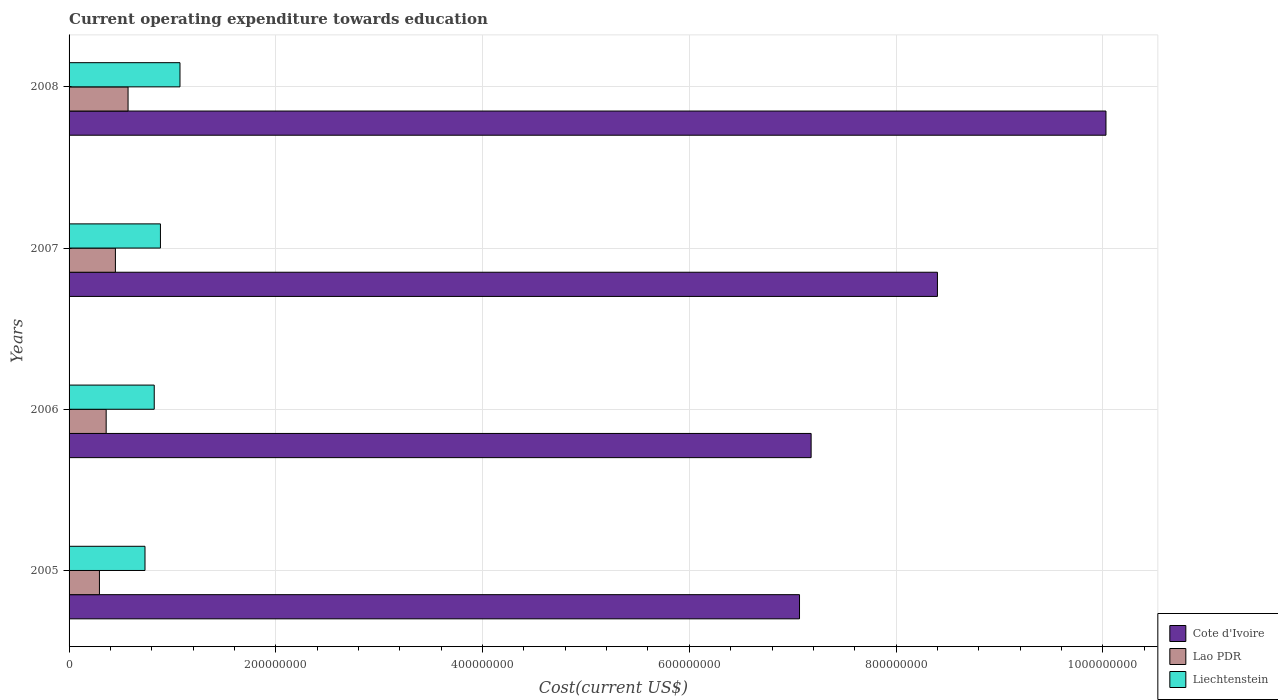How many different coloured bars are there?
Offer a very short reply. 3. Are the number of bars per tick equal to the number of legend labels?
Offer a very short reply. Yes. Are the number of bars on each tick of the Y-axis equal?
Your answer should be very brief. Yes. How many bars are there on the 2nd tick from the top?
Provide a succinct answer. 3. How many bars are there on the 1st tick from the bottom?
Provide a succinct answer. 3. What is the expenditure towards education in Liechtenstein in 2008?
Your answer should be very brief. 1.07e+08. Across all years, what is the maximum expenditure towards education in Liechtenstein?
Offer a terse response. 1.07e+08. Across all years, what is the minimum expenditure towards education in Cote d'Ivoire?
Keep it short and to the point. 7.07e+08. In which year was the expenditure towards education in Cote d'Ivoire minimum?
Provide a short and direct response. 2005. What is the total expenditure towards education in Lao PDR in the graph?
Keep it short and to the point. 1.67e+08. What is the difference between the expenditure towards education in Liechtenstein in 2006 and that in 2007?
Ensure brevity in your answer.  -6.00e+06. What is the difference between the expenditure towards education in Liechtenstein in 2006 and the expenditure towards education in Lao PDR in 2008?
Offer a terse response. 2.53e+07. What is the average expenditure towards education in Liechtenstein per year?
Keep it short and to the point. 8.79e+07. In the year 2007, what is the difference between the expenditure towards education in Liechtenstein and expenditure towards education in Lao PDR?
Ensure brevity in your answer.  4.36e+07. What is the ratio of the expenditure towards education in Lao PDR in 2007 to that in 2008?
Make the answer very short. 0.79. Is the difference between the expenditure towards education in Liechtenstein in 2005 and 2007 greater than the difference between the expenditure towards education in Lao PDR in 2005 and 2007?
Keep it short and to the point. Yes. What is the difference between the highest and the second highest expenditure towards education in Lao PDR?
Make the answer very short. 1.22e+07. What is the difference between the highest and the lowest expenditure towards education in Liechtenstein?
Make the answer very short. 3.39e+07. What does the 2nd bar from the top in 2007 represents?
Your response must be concise. Lao PDR. What does the 3rd bar from the bottom in 2006 represents?
Your answer should be very brief. Liechtenstein. Is it the case that in every year, the sum of the expenditure towards education in Cote d'Ivoire and expenditure towards education in Lao PDR is greater than the expenditure towards education in Liechtenstein?
Your response must be concise. Yes. How many years are there in the graph?
Make the answer very short. 4. Are the values on the major ticks of X-axis written in scientific E-notation?
Your answer should be compact. No. Does the graph contain grids?
Offer a very short reply. Yes. Where does the legend appear in the graph?
Provide a short and direct response. Bottom right. How many legend labels are there?
Your answer should be compact. 3. How are the legend labels stacked?
Your response must be concise. Vertical. What is the title of the graph?
Your response must be concise. Current operating expenditure towards education. Does "Sint Maarten (Dutch part)" appear as one of the legend labels in the graph?
Make the answer very short. No. What is the label or title of the X-axis?
Ensure brevity in your answer.  Cost(current US$). What is the Cost(current US$) of Cote d'Ivoire in 2005?
Your answer should be compact. 7.07e+08. What is the Cost(current US$) of Lao PDR in 2005?
Offer a terse response. 2.94e+07. What is the Cost(current US$) in Liechtenstein in 2005?
Provide a succinct answer. 7.34e+07. What is the Cost(current US$) of Cote d'Ivoire in 2006?
Offer a terse response. 7.18e+08. What is the Cost(current US$) of Lao PDR in 2006?
Your response must be concise. 3.59e+07. What is the Cost(current US$) in Liechtenstein in 2006?
Your answer should be very brief. 8.24e+07. What is the Cost(current US$) in Cote d'Ivoire in 2007?
Your answer should be compact. 8.40e+08. What is the Cost(current US$) of Lao PDR in 2007?
Give a very brief answer. 4.48e+07. What is the Cost(current US$) of Liechtenstein in 2007?
Give a very brief answer. 8.84e+07. What is the Cost(current US$) in Cote d'Ivoire in 2008?
Give a very brief answer. 1.00e+09. What is the Cost(current US$) in Lao PDR in 2008?
Ensure brevity in your answer.  5.71e+07. What is the Cost(current US$) of Liechtenstein in 2008?
Offer a terse response. 1.07e+08. Across all years, what is the maximum Cost(current US$) in Cote d'Ivoire?
Offer a very short reply. 1.00e+09. Across all years, what is the maximum Cost(current US$) in Lao PDR?
Provide a short and direct response. 5.71e+07. Across all years, what is the maximum Cost(current US$) of Liechtenstein?
Provide a succinct answer. 1.07e+08. Across all years, what is the minimum Cost(current US$) in Cote d'Ivoire?
Your answer should be very brief. 7.07e+08. Across all years, what is the minimum Cost(current US$) of Lao PDR?
Ensure brevity in your answer.  2.94e+07. Across all years, what is the minimum Cost(current US$) of Liechtenstein?
Offer a very short reply. 7.34e+07. What is the total Cost(current US$) in Cote d'Ivoire in the graph?
Provide a short and direct response. 3.27e+09. What is the total Cost(current US$) in Lao PDR in the graph?
Your answer should be very brief. 1.67e+08. What is the total Cost(current US$) of Liechtenstein in the graph?
Your answer should be very brief. 3.52e+08. What is the difference between the Cost(current US$) in Cote d'Ivoire in 2005 and that in 2006?
Keep it short and to the point. -1.12e+07. What is the difference between the Cost(current US$) of Lao PDR in 2005 and that in 2006?
Ensure brevity in your answer.  -6.52e+06. What is the difference between the Cost(current US$) of Liechtenstein in 2005 and that in 2006?
Your answer should be very brief. -8.94e+06. What is the difference between the Cost(current US$) in Cote d'Ivoire in 2005 and that in 2007?
Offer a terse response. -1.33e+08. What is the difference between the Cost(current US$) of Lao PDR in 2005 and that in 2007?
Give a very brief answer. -1.55e+07. What is the difference between the Cost(current US$) in Liechtenstein in 2005 and that in 2007?
Your answer should be very brief. -1.49e+07. What is the difference between the Cost(current US$) of Cote d'Ivoire in 2005 and that in 2008?
Your answer should be very brief. -2.96e+08. What is the difference between the Cost(current US$) of Lao PDR in 2005 and that in 2008?
Offer a very short reply. -2.77e+07. What is the difference between the Cost(current US$) in Liechtenstein in 2005 and that in 2008?
Your response must be concise. -3.39e+07. What is the difference between the Cost(current US$) in Cote d'Ivoire in 2006 and that in 2007?
Give a very brief answer. -1.22e+08. What is the difference between the Cost(current US$) of Lao PDR in 2006 and that in 2007?
Provide a succinct answer. -8.94e+06. What is the difference between the Cost(current US$) of Liechtenstein in 2006 and that in 2007?
Your answer should be very brief. -6.00e+06. What is the difference between the Cost(current US$) in Cote d'Ivoire in 2006 and that in 2008?
Offer a terse response. -2.85e+08. What is the difference between the Cost(current US$) of Lao PDR in 2006 and that in 2008?
Give a very brief answer. -2.12e+07. What is the difference between the Cost(current US$) of Liechtenstein in 2006 and that in 2008?
Ensure brevity in your answer.  -2.49e+07. What is the difference between the Cost(current US$) in Cote d'Ivoire in 2007 and that in 2008?
Offer a terse response. -1.63e+08. What is the difference between the Cost(current US$) in Lao PDR in 2007 and that in 2008?
Your answer should be very brief. -1.22e+07. What is the difference between the Cost(current US$) of Liechtenstein in 2007 and that in 2008?
Ensure brevity in your answer.  -1.89e+07. What is the difference between the Cost(current US$) in Cote d'Ivoire in 2005 and the Cost(current US$) in Lao PDR in 2006?
Give a very brief answer. 6.71e+08. What is the difference between the Cost(current US$) in Cote d'Ivoire in 2005 and the Cost(current US$) in Liechtenstein in 2006?
Provide a short and direct response. 6.24e+08. What is the difference between the Cost(current US$) of Lao PDR in 2005 and the Cost(current US$) of Liechtenstein in 2006?
Offer a terse response. -5.30e+07. What is the difference between the Cost(current US$) in Cote d'Ivoire in 2005 and the Cost(current US$) in Lao PDR in 2007?
Your answer should be very brief. 6.62e+08. What is the difference between the Cost(current US$) in Cote d'Ivoire in 2005 and the Cost(current US$) in Liechtenstein in 2007?
Offer a terse response. 6.18e+08. What is the difference between the Cost(current US$) in Lao PDR in 2005 and the Cost(current US$) in Liechtenstein in 2007?
Ensure brevity in your answer.  -5.90e+07. What is the difference between the Cost(current US$) of Cote d'Ivoire in 2005 and the Cost(current US$) of Lao PDR in 2008?
Your answer should be very brief. 6.50e+08. What is the difference between the Cost(current US$) in Cote d'Ivoire in 2005 and the Cost(current US$) in Liechtenstein in 2008?
Provide a succinct answer. 5.99e+08. What is the difference between the Cost(current US$) in Lao PDR in 2005 and the Cost(current US$) in Liechtenstein in 2008?
Ensure brevity in your answer.  -7.79e+07. What is the difference between the Cost(current US$) of Cote d'Ivoire in 2006 and the Cost(current US$) of Lao PDR in 2007?
Offer a terse response. 6.73e+08. What is the difference between the Cost(current US$) in Cote d'Ivoire in 2006 and the Cost(current US$) in Liechtenstein in 2007?
Offer a very short reply. 6.29e+08. What is the difference between the Cost(current US$) in Lao PDR in 2006 and the Cost(current US$) in Liechtenstein in 2007?
Offer a very short reply. -5.25e+07. What is the difference between the Cost(current US$) in Cote d'Ivoire in 2006 and the Cost(current US$) in Lao PDR in 2008?
Provide a short and direct response. 6.61e+08. What is the difference between the Cost(current US$) in Cote d'Ivoire in 2006 and the Cost(current US$) in Liechtenstein in 2008?
Ensure brevity in your answer.  6.11e+08. What is the difference between the Cost(current US$) of Lao PDR in 2006 and the Cost(current US$) of Liechtenstein in 2008?
Your response must be concise. -7.14e+07. What is the difference between the Cost(current US$) of Cote d'Ivoire in 2007 and the Cost(current US$) of Lao PDR in 2008?
Offer a terse response. 7.83e+08. What is the difference between the Cost(current US$) in Cote d'Ivoire in 2007 and the Cost(current US$) in Liechtenstein in 2008?
Offer a terse response. 7.33e+08. What is the difference between the Cost(current US$) of Lao PDR in 2007 and the Cost(current US$) of Liechtenstein in 2008?
Provide a succinct answer. -6.25e+07. What is the average Cost(current US$) in Cote d'Ivoire per year?
Keep it short and to the point. 8.17e+08. What is the average Cost(current US$) in Lao PDR per year?
Ensure brevity in your answer.  4.18e+07. What is the average Cost(current US$) in Liechtenstein per year?
Give a very brief answer. 8.79e+07. In the year 2005, what is the difference between the Cost(current US$) in Cote d'Ivoire and Cost(current US$) in Lao PDR?
Your answer should be compact. 6.77e+08. In the year 2005, what is the difference between the Cost(current US$) in Cote d'Ivoire and Cost(current US$) in Liechtenstein?
Keep it short and to the point. 6.33e+08. In the year 2005, what is the difference between the Cost(current US$) in Lao PDR and Cost(current US$) in Liechtenstein?
Ensure brevity in your answer.  -4.41e+07. In the year 2006, what is the difference between the Cost(current US$) in Cote d'Ivoire and Cost(current US$) in Lao PDR?
Give a very brief answer. 6.82e+08. In the year 2006, what is the difference between the Cost(current US$) of Cote d'Ivoire and Cost(current US$) of Liechtenstein?
Keep it short and to the point. 6.35e+08. In the year 2006, what is the difference between the Cost(current US$) of Lao PDR and Cost(current US$) of Liechtenstein?
Ensure brevity in your answer.  -4.65e+07. In the year 2007, what is the difference between the Cost(current US$) of Cote d'Ivoire and Cost(current US$) of Lao PDR?
Ensure brevity in your answer.  7.95e+08. In the year 2007, what is the difference between the Cost(current US$) of Cote d'Ivoire and Cost(current US$) of Liechtenstein?
Keep it short and to the point. 7.52e+08. In the year 2007, what is the difference between the Cost(current US$) in Lao PDR and Cost(current US$) in Liechtenstein?
Make the answer very short. -4.36e+07. In the year 2008, what is the difference between the Cost(current US$) in Cote d'Ivoire and Cost(current US$) in Lao PDR?
Give a very brief answer. 9.46e+08. In the year 2008, what is the difference between the Cost(current US$) in Cote d'Ivoire and Cost(current US$) in Liechtenstein?
Give a very brief answer. 8.96e+08. In the year 2008, what is the difference between the Cost(current US$) in Lao PDR and Cost(current US$) in Liechtenstein?
Give a very brief answer. -5.02e+07. What is the ratio of the Cost(current US$) of Cote d'Ivoire in 2005 to that in 2006?
Offer a terse response. 0.98. What is the ratio of the Cost(current US$) in Lao PDR in 2005 to that in 2006?
Offer a very short reply. 0.82. What is the ratio of the Cost(current US$) in Liechtenstein in 2005 to that in 2006?
Your answer should be compact. 0.89. What is the ratio of the Cost(current US$) in Cote d'Ivoire in 2005 to that in 2007?
Ensure brevity in your answer.  0.84. What is the ratio of the Cost(current US$) of Lao PDR in 2005 to that in 2007?
Your response must be concise. 0.66. What is the ratio of the Cost(current US$) in Liechtenstein in 2005 to that in 2007?
Offer a terse response. 0.83. What is the ratio of the Cost(current US$) of Cote d'Ivoire in 2005 to that in 2008?
Offer a terse response. 0.7. What is the ratio of the Cost(current US$) in Lao PDR in 2005 to that in 2008?
Keep it short and to the point. 0.51. What is the ratio of the Cost(current US$) in Liechtenstein in 2005 to that in 2008?
Make the answer very short. 0.68. What is the ratio of the Cost(current US$) of Cote d'Ivoire in 2006 to that in 2007?
Provide a succinct answer. 0.85. What is the ratio of the Cost(current US$) in Lao PDR in 2006 to that in 2007?
Keep it short and to the point. 0.8. What is the ratio of the Cost(current US$) in Liechtenstein in 2006 to that in 2007?
Provide a short and direct response. 0.93. What is the ratio of the Cost(current US$) of Cote d'Ivoire in 2006 to that in 2008?
Provide a short and direct response. 0.72. What is the ratio of the Cost(current US$) of Lao PDR in 2006 to that in 2008?
Give a very brief answer. 0.63. What is the ratio of the Cost(current US$) of Liechtenstein in 2006 to that in 2008?
Offer a terse response. 0.77. What is the ratio of the Cost(current US$) in Cote d'Ivoire in 2007 to that in 2008?
Provide a succinct answer. 0.84. What is the ratio of the Cost(current US$) of Lao PDR in 2007 to that in 2008?
Provide a short and direct response. 0.79. What is the ratio of the Cost(current US$) of Liechtenstein in 2007 to that in 2008?
Provide a short and direct response. 0.82. What is the difference between the highest and the second highest Cost(current US$) in Cote d'Ivoire?
Make the answer very short. 1.63e+08. What is the difference between the highest and the second highest Cost(current US$) of Lao PDR?
Offer a very short reply. 1.22e+07. What is the difference between the highest and the second highest Cost(current US$) in Liechtenstein?
Offer a very short reply. 1.89e+07. What is the difference between the highest and the lowest Cost(current US$) of Cote d'Ivoire?
Your response must be concise. 2.96e+08. What is the difference between the highest and the lowest Cost(current US$) of Lao PDR?
Offer a very short reply. 2.77e+07. What is the difference between the highest and the lowest Cost(current US$) of Liechtenstein?
Offer a very short reply. 3.39e+07. 